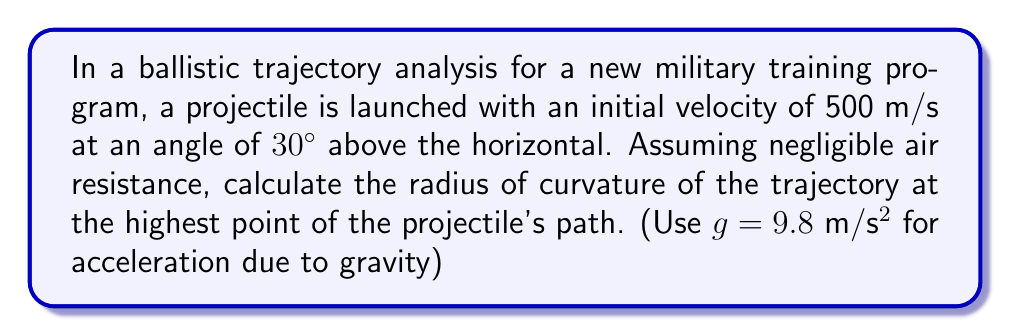Give your solution to this math problem. Let's approach this step-by-step:

1) First, we need to understand that the radius of curvature (R) at any point of a projectile's trajectory is given by:

   $$R = \frac{(v_x^2 + v_y^2)^{3/2}}{g|v_x|}$$

   Where $v_x$ and $v_y$ are the horizontal and vertical components of velocity, respectively.

2) At the highest point, $v_y = 0$, so our equation simplifies to:

   $$R = \frac{v_x^3}{g|v_x|} = \frac{v_x^2}{g}$$

3) Now, we need to find $v_x$. The initial velocity components are:
   
   $v_x = v_0 \cos\theta = 500 \cos 30° = 500 \cdot \frac{\sqrt{3}}{2} = 250\sqrt{3}$ m/s
   
   $v_y = v_0 \sin\theta = 500 \sin 30° = 500 \cdot \frac{1}{2} = 250$ m/s

4) The horizontal velocity $v_x$ remains constant throughout the trajectory due to the assumption of negligible air resistance.

5) Now we can substitute into our simplified equation:

   $$R = \frac{(250\sqrt{3})^2}{9.8} = \frac{187500}{9.8} \approx 19132.65$$ m

Therefore, the radius of curvature at the highest point is approximately 19,132.65 meters.
Answer: 19,132.65 m 